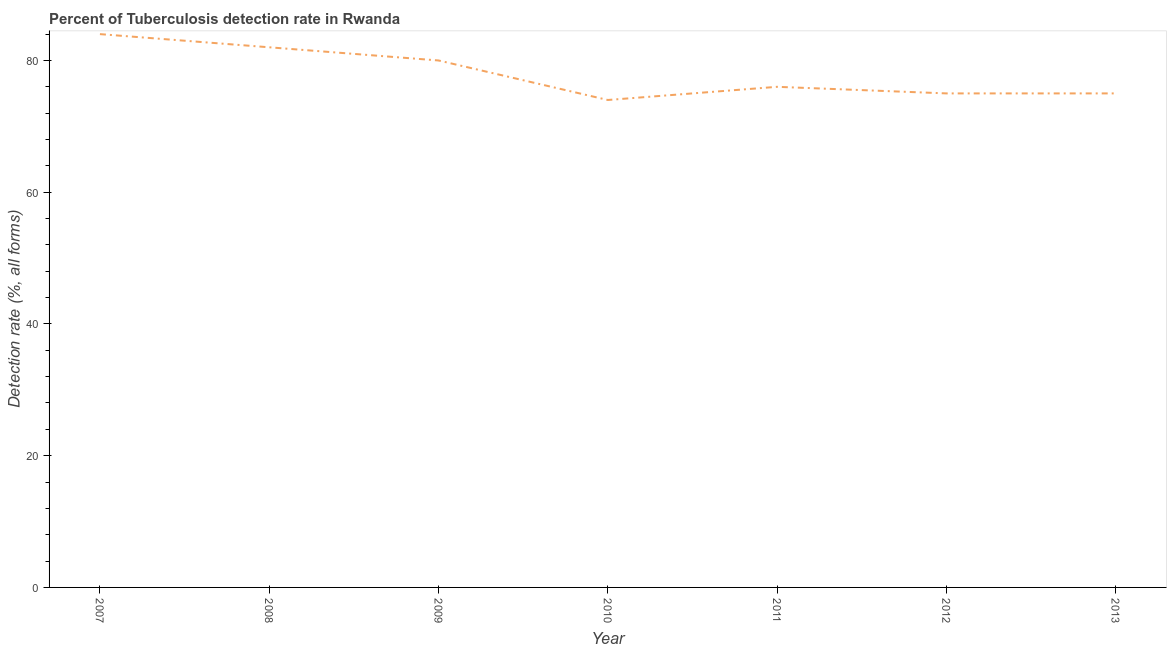What is the detection rate of tuberculosis in 2010?
Keep it short and to the point. 74. Across all years, what is the maximum detection rate of tuberculosis?
Keep it short and to the point. 84. Across all years, what is the minimum detection rate of tuberculosis?
Give a very brief answer. 74. In which year was the detection rate of tuberculosis maximum?
Provide a short and direct response. 2007. What is the sum of the detection rate of tuberculosis?
Your answer should be compact. 546. What is the difference between the detection rate of tuberculosis in 2009 and 2011?
Keep it short and to the point. 4. What is the median detection rate of tuberculosis?
Provide a short and direct response. 76. In how many years, is the detection rate of tuberculosis greater than 56 %?
Ensure brevity in your answer.  7. Do a majority of the years between 2013 and 2009 (inclusive) have detection rate of tuberculosis greater than 56 %?
Keep it short and to the point. Yes. What is the ratio of the detection rate of tuberculosis in 2009 to that in 2010?
Offer a terse response. 1.08. Is the detection rate of tuberculosis in 2009 less than that in 2012?
Your response must be concise. No. Is the difference between the detection rate of tuberculosis in 2008 and 2009 greater than the difference between any two years?
Your response must be concise. No. What is the difference between the highest and the second highest detection rate of tuberculosis?
Your answer should be compact. 2. What is the difference between the highest and the lowest detection rate of tuberculosis?
Make the answer very short. 10. How many lines are there?
Offer a very short reply. 1. How many years are there in the graph?
Make the answer very short. 7. Are the values on the major ticks of Y-axis written in scientific E-notation?
Offer a very short reply. No. Does the graph contain grids?
Give a very brief answer. No. What is the title of the graph?
Offer a very short reply. Percent of Tuberculosis detection rate in Rwanda. What is the label or title of the X-axis?
Give a very brief answer. Year. What is the label or title of the Y-axis?
Your response must be concise. Detection rate (%, all forms). What is the Detection rate (%, all forms) in 2007?
Offer a terse response. 84. What is the Detection rate (%, all forms) of 2009?
Provide a succinct answer. 80. What is the Detection rate (%, all forms) in 2011?
Offer a very short reply. 76. What is the Detection rate (%, all forms) of 2012?
Provide a short and direct response. 75. What is the Detection rate (%, all forms) in 2013?
Provide a short and direct response. 75. What is the difference between the Detection rate (%, all forms) in 2007 and 2010?
Give a very brief answer. 10. What is the difference between the Detection rate (%, all forms) in 2007 and 2011?
Offer a very short reply. 8. What is the difference between the Detection rate (%, all forms) in 2008 and 2009?
Provide a succinct answer. 2. What is the difference between the Detection rate (%, all forms) in 2008 and 2012?
Make the answer very short. 7. What is the difference between the Detection rate (%, all forms) in 2008 and 2013?
Offer a terse response. 7. What is the difference between the Detection rate (%, all forms) in 2010 and 2012?
Your answer should be compact. -1. What is the difference between the Detection rate (%, all forms) in 2011 and 2012?
Provide a short and direct response. 1. What is the difference between the Detection rate (%, all forms) in 2011 and 2013?
Provide a succinct answer. 1. What is the difference between the Detection rate (%, all forms) in 2012 and 2013?
Your answer should be compact. 0. What is the ratio of the Detection rate (%, all forms) in 2007 to that in 2008?
Give a very brief answer. 1.02. What is the ratio of the Detection rate (%, all forms) in 2007 to that in 2010?
Offer a terse response. 1.14. What is the ratio of the Detection rate (%, all forms) in 2007 to that in 2011?
Your answer should be compact. 1.1. What is the ratio of the Detection rate (%, all forms) in 2007 to that in 2012?
Offer a terse response. 1.12. What is the ratio of the Detection rate (%, all forms) in 2007 to that in 2013?
Provide a succinct answer. 1.12. What is the ratio of the Detection rate (%, all forms) in 2008 to that in 2010?
Make the answer very short. 1.11. What is the ratio of the Detection rate (%, all forms) in 2008 to that in 2011?
Keep it short and to the point. 1.08. What is the ratio of the Detection rate (%, all forms) in 2008 to that in 2012?
Provide a short and direct response. 1.09. What is the ratio of the Detection rate (%, all forms) in 2008 to that in 2013?
Offer a very short reply. 1.09. What is the ratio of the Detection rate (%, all forms) in 2009 to that in 2010?
Offer a very short reply. 1.08. What is the ratio of the Detection rate (%, all forms) in 2009 to that in 2011?
Your answer should be compact. 1.05. What is the ratio of the Detection rate (%, all forms) in 2009 to that in 2012?
Offer a very short reply. 1.07. What is the ratio of the Detection rate (%, all forms) in 2009 to that in 2013?
Give a very brief answer. 1.07. What is the ratio of the Detection rate (%, all forms) in 2010 to that in 2013?
Offer a very short reply. 0.99. What is the ratio of the Detection rate (%, all forms) in 2011 to that in 2012?
Offer a very short reply. 1.01. What is the ratio of the Detection rate (%, all forms) in 2011 to that in 2013?
Your answer should be very brief. 1.01. What is the ratio of the Detection rate (%, all forms) in 2012 to that in 2013?
Your answer should be compact. 1. 